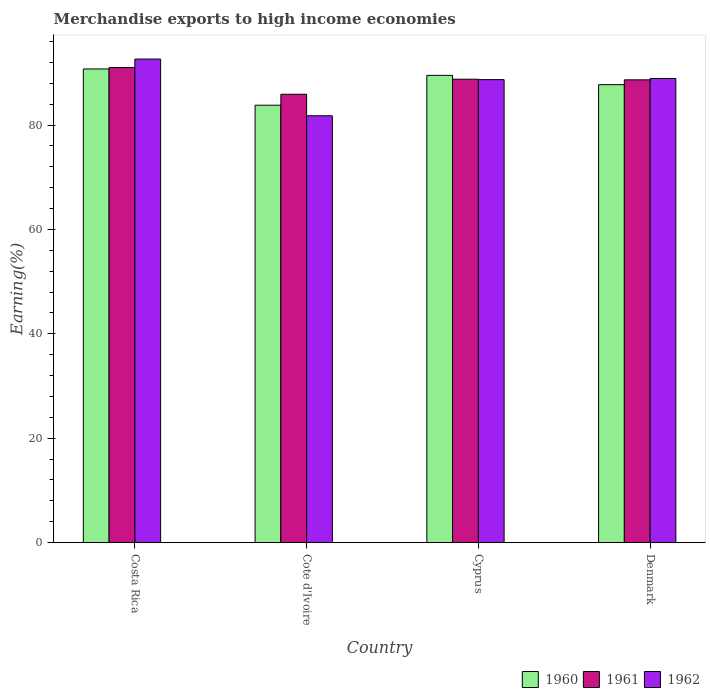How many different coloured bars are there?
Keep it short and to the point. 3. How many groups of bars are there?
Make the answer very short. 4. What is the label of the 1st group of bars from the left?
Your answer should be very brief. Costa Rica. What is the percentage of amount earned from merchandise exports in 1961 in Denmark?
Provide a succinct answer. 88.66. Across all countries, what is the maximum percentage of amount earned from merchandise exports in 1961?
Make the answer very short. 91.01. Across all countries, what is the minimum percentage of amount earned from merchandise exports in 1960?
Keep it short and to the point. 83.8. In which country was the percentage of amount earned from merchandise exports in 1961 minimum?
Your answer should be compact. Cote d'Ivoire. What is the total percentage of amount earned from merchandise exports in 1961 in the graph?
Your answer should be compact. 354.33. What is the difference between the percentage of amount earned from merchandise exports in 1961 in Costa Rica and that in Denmark?
Provide a succinct answer. 2.36. What is the difference between the percentage of amount earned from merchandise exports in 1960 in Cyprus and the percentage of amount earned from merchandise exports in 1961 in Cote d'Ivoire?
Keep it short and to the point. 3.62. What is the average percentage of amount earned from merchandise exports in 1960 per country?
Make the answer very short. 87.94. What is the difference between the percentage of amount earned from merchandise exports of/in 1960 and percentage of amount earned from merchandise exports of/in 1961 in Denmark?
Ensure brevity in your answer.  -0.93. What is the ratio of the percentage of amount earned from merchandise exports in 1961 in Costa Rica to that in Cote d'Ivoire?
Make the answer very short. 1.06. Is the percentage of amount earned from merchandise exports in 1960 in Costa Rica less than that in Cote d'Ivoire?
Provide a succinct answer. No. Is the difference between the percentage of amount earned from merchandise exports in 1960 in Cote d'Ivoire and Denmark greater than the difference between the percentage of amount earned from merchandise exports in 1961 in Cote d'Ivoire and Denmark?
Your answer should be compact. No. What is the difference between the highest and the second highest percentage of amount earned from merchandise exports in 1961?
Provide a short and direct response. 0.12. What is the difference between the highest and the lowest percentage of amount earned from merchandise exports in 1961?
Keep it short and to the point. 5.12. In how many countries, is the percentage of amount earned from merchandise exports in 1962 greater than the average percentage of amount earned from merchandise exports in 1962 taken over all countries?
Your answer should be compact. 3. Is the sum of the percentage of amount earned from merchandise exports in 1961 in Costa Rica and Denmark greater than the maximum percentage of amount earned from merchandise exports in 1962 across all countries?
Offer a very short reply. Yes. What does the 1st bar from the left in Cyprus represents?
Offer a very short reply. 1960. What does the 1st bar from the right in Denmark represents?
Keep it short and to the point. 1962. Is it the case that in every country, the sum of the percentage of amount earned from merchandise exports in 1960 and percentage of amount earned from merchandise exports in 1961 is greater than the percentage of amount earned from merchandise exports in 1962?
Ensure brevity in your answer.  Yes. How many bars are there?
Offer a terse response. 12. How many countries are there in the graph?
Give a very brief answer. 4. How are the legend labels stacked?
Provide a short and direct response. Horizontal. What is the title of the graph?
Offer a very short reply. Merchandise exports to high income economies. What is the label or title of the X-axis?
Your answer should be compact. Country. What is the label or title of the Y-axis?
Provide a succinct answer. Earning(%). What is the Earning(%) in 1960 in Costa Rica?
Keep it short and to the point. 90.74. What is the Earning(%) of 1961 in Costa Rica?
Ensure brevity in your answer.  91.01. What is the Earning(%) of 1962 in Costa Rica?
Ensure brevity in your answer.  92.64. What is the Earning(%) of 1960 in Cote d'Ivoire?
Your answer should be very brief. 83.8. What is the Earning(%) of 1961 in Cote d'Ivoire?
Provide a short and direct response. 85.89. What is the Earning(%) in 1962 in Cote d'Ivoire?
Make the answer very short. 81.77. What is the Earning(%) in 1960 in Cyprus?
Make the answer very short. 89.51. What is the Earning(%) of 1961 in Cyprus?
Your answer should be very brief. 88.78. What is the Earning(%) of 1962 in Cyprus?
Keep it short and to the point. 88.7. What is the Earning(%) in 1960 in Denmark?
Your answer should be very brief. 87.73. What is the Earning(%) in 1961 in Denmark?
Keep it short and to the point. 88.66. What is the Earning(%) of 1962 in Denmark?
Offer a very short reply. 88.91. Across all countries, what is the maximum Earning(%) of 1960?
Make the answer very short. 90.74. Across all countries, what is the maximum Earning(%) of 1961?
Provide a succinct answer. 91.01. Across all countries, what is the maximum Earning(%) in 1962?
Offer a very short reply. 92.64. Across all countries, what is the minimum Earning(%) of 1960?
Offer a terse response. 83.8. Across all countries, what is the minimum Earning(%) in 1961?
Offer a very short reply. 85.89. Across all countries, what is the minimum Earning(%) in 1962?
Make the answer very short. 81.77. What is the total Earning(%) in 1960 in the graph?
Offer a terse response. 351.78. What is the total Earning(%) in 1961 in the graph?
Provide a succinct answer. 354.33. What is the total Earning(%) of 1962 in the graph?
Provide a short and direct response. 352.01. What is the difference between the Earning(%) of 1960 in Costa Rica and that in Cote d'Ivoire?
Your answer should be very brief. 6.95. What is the difference between the Earning(%) in 1961 in Costa Rica and that in Cote d'Ivoire?
Offer a terse response. 5.12. What is the difference between the Earning(%) of 1962 in Costa Rica and that in Cote d'Ivoire?
Your answer should be very brief. 10.87. What is the difference between the Earning(%) of 1960 in Costa Rica and that in Cyprus?
Your response must be concise. 1.23. What is the difference between the Earning(%) in 1961 in Costa Rica and that in Cyprus?
Your answer should be compact. 2.24. What is the difference between the Earning(%) in 1962 in Costa Rica and that in Cyprus?
Give a very brief answer. 3.94. What is the difference between the Earning(%) in 1960 in Costa Rica and that in Denmark?
Your response must be concise. 3.01. What is the difference between the Earning(%) in 1961 in Costa Rica and that in Denmark?
Keep it short and to the point. 2.36. What is the difference between the Earning(%) in 1962 in Costa Rica and that in Denmark?
Offer a very short reply. 3.73. What is the difference between the Earning(%) in 1960 in Cote d'Ivoire and that in Cyprus?
Your answer should be compact. -5.72. What is the difference between the Earning(%) of 1961 in Cote d'Ivoire and that in Cyprus?
Your answer should be very brief. -2.88. What is the difference between the Earning(%) in 1962 in Cote d'Ivoire and that in Cyprus?
Offer a very short reply. -6.92. What is the difference between the Earning(%) in 1960 in Cote d'Ivoire and that in Denmark?
Make the answer very short. -3.93. What is the difference between the Earning(%) in 1961 in Cote d'Ivoire and that in Denmark?
Your response must be concise. -2.76. What is the difference between the Earning(%) of 1962 in Cote d'Ivoire and that in Denmark?
Keep it short and to the point. -7.14. What is the difference between the Earning(%) of 1960 in Cyprus and that in Denmark?
Your answer should be compact. 1.78. What is the difference between the Earning(%) in 1961 in Cyprus and that in Denmark?
Offer a terse response. 0.12. What is the difference between the Earning(%) of 1962 in Cyprus and that in Denmark?
Offer a very short reply. -0.21. What is the difference between the Earning(%) of 1960 in Costa Rica and the Earning(%) of 1961 in Cote d'Ivoire?
Provide a succinct answer. 4.85. What is the difference between the Earning(%) of 1960 in Costa Rica and the Earning(%) of 1962 in Cote d'Ivoire?
Offer a terse response. 8.97. What is the difference between the Earning(%) of 1961 in Costa Rica and the Earning(%) of 1962 in Cote d'Ivoire?
Ensure brevity in your answer.  9.24. What is the difference between the Earning(%) in 1960 in Costa Rica and the Earning(%) in 1961 in Cyprus?
Your response must be concise. 1.97. What is the difference between the Earning(%) of 1960 in Costa Rica and the Earning(%) of 1962 in Cyprus?
Offer a terse response. 2.05. What is the difference between the Earning(%) of 1961 in Costa Rica and the Earning(%) of 1962 in Cyprus?
Give a very brief answer. 2.32. What is the difference between the Earning(%) of 1960 in Costa Rica and the Earning(%) of 1961 in Denmark?
Give a very brief answer. 2.09. What is the difference between the Earning(%) in 1960 in Costa Rica and the Earning(%) in 1962 in Denmark?
Provide a short and direct response. 1.83. What is the difference between the Earning(%) of 1961 in Costa Rica and the Earning(%) of 1962 in Denmark?
Give a very brief answer. 2.1. What is the difference between the Earning(%) in 1960 in Cote d'Ivoire and the Earning(%) in 1961 in Cyprus?
Provide a short and direct response. -4.98. What is the difference between the Earning(%) of 1960 in Cote d'Ivoire and the Earning(%) of 1962 in Cyprus?
Provide a succinct answer. -4.9. What is the difference between the Earning(%) in 1961 in Cote d'Ivoire and the Earning(%) in 1962 in Cyprus?
Keep it short and to the point. -2.8. What is the difference between the Earning(%) in 1960 in Cote d'Ivoire and the Earning(%) in 1961 in Denmark?
Offer a very short reply. -4.86. What is the difference between the Earning(%) in 1960 in Cote d'Ivoire and the Earning(%) in 1962 in Denmark?
Provide a short and direct response. -5.11. What is the difference between the Earning(%) in 1961 in Cote d'Ivoire and the Earning(%) in 1962 in Denmark?
Keep it short and to the point. -3.02. What is the difference between the Earning(%) of 1960 in Cyprus and the Earning(%) of 1961 in Denmark?
Your answer should be compact. 0.86. What is the difference between the Earning(%) of 1960 in Cyprus and the Earning(%) of 1962 in Denmark?
Your answer should be very brief. 0.6. What is the difference between the Earning(%) of 1961 in Cyprus and the Earning(%) of 1962 in Denmark?
Your response must be concise. -0.13. What is the average Earning(%) in 1960 per country?
Make the answer very short. 87.94. What is the average Earning(%) in 1961 per country?
Make the answer very short. 88.58. What is the average Earning(%) in 1962 per country?
Provide a short and direct response. 88. What is the difference between the Earning(%) in 1960 and Earning(%) in 1961 in Costa Rica?
Offer a terse response. -0.27. What is the difference between the Earning(%) of 1960 and Earning(%) of 1962 in Costa Rica?
Make the answer very short. -1.9. What is the difference between the Earning(%) in 1961 and Earning(%) in 1962 in Costa Rica?
Your answer should be compact. -1.63. What is the difference between the Earning(%) of 1960 and Earning(%) of 1961 in Cote d'Ivoire?
Make the answer very short. -2.1. What is the difference between the Earning(%) in 1960 and Earning(%) in 1962 in Cote d'Ivoire?
Give a very brief answer. 2.02. What is the difference between the Earning(%) of 1961 and Earning(%) of 1962 in Cote d'Ivoire?
Provide a short and direct response. 4.12. What is the difference between the Earning(%) in 1960 and Earning(%) in 1961 in Cyprus?
Provide a succinct answer. 0.74. What is the difference between the Earning(%) in 1960 and Earning(%) in 1962 in Cyprus?
Your answer should be compact. 0.82. What is the difference between the Earning(%) in 1961 and Earning(%) in 1962 in Cyprus?
Your response must be concise. 0.08. What is the difference between the Earning(%) of 1960 and Earning(%) of 1961 in Denmark?
Your response must be concise. -0.93. What is the difference between the Earning(%) in 1960 and Earning(%) in 1962 in Denmark?
Your response must be concise. -1.18. What is the difference between the Earning(%) in 1961 and Earning(%) in 1962 in Denmark?
Provide a short and direct response. -0.25. What is the ratio of the Earning(%) of 1960 in Costa Rica to that in Cote d'Ivoire?
Make the answer very short. 1.08. What is the ratio of the Earning(%) in 1961 in Costa Rica to that in Cote d'Ivoire?
Ensure brevity in your answer.  1.06. What is the ratio of the Earning(%) in 1962 in Costa Rica to that in Cote d'Ivoire?
Ensure brevity in your answer.  1.13. What is the ratio of the Earning(%) in 1960 in Costa Rica to that in Cyprus?
Give a very brief answer. 1.01. What is the ratio of the Earning(%) of 1961 in Costa Rica to that in Cyprus?
Your answer should be very brief. 1.03. What is the ratio of the Earning(%) of 1962 in Costa Rica to that in Cyprus?
Offer a terse response. 1.04. What is the ratio of the Earning(%) of 1960 in Costa Rica to that in Denmark?
Your answer should be very brief. 1.03. What is the ratio of the Earning(%) in 1961 in Costa Rica to that in Denmark?
Keep it short and to the point. 1.03. What is the ratio of the Earning(%) of 1962 in Costa Rica to that in Denmark?
Make the answer very short. 1.04. What is the ratio of the Earning(%) of 1960 in Cote d'Ivoire to that in Cyprus?
Your response must be concise. 0.94. What is the ratio of the Earning(%) of 1961 in Cote d'Ivoire to that in Cyprus?
Ensure brevity in your answer.  0.97. What is the ratio of the Earning(%) in 1962 in Cote d'Ivoire to that in Cyprus?
Ensure brevity in your answer.  0.92. What is the ratio of the Earning(%) of 1960 in Cote d'Ivoire to that in Denmark?
Make the answer very short. 0.96. What is the ratio of the Earning(%) of 1961 in Cote d'Ivoire to that in Denmark?
Make the answer very short. 0.97. What is the ratio of the Earning(%) of 1962 in Cote d'Ivoire to that in Denmark?
Your answer should be compact. 0.92. What is the ratio of the Earning(%) of 1960 in Cyprus to that in Denmark?
Make the answer very short. 1.02. What is the ratio of the Earning(%) of 1962 in Cyprus to that in Denmark?
Make the answer very short. 1. What is the difference between the highest and the second highest Earning(%) of 1960?
Give a very brief answer. 1.23. What is the difference between the highest and the second highest Earning(%) in 1961?
Provide a succinct answer. 2.24. What is the difference between the highest and the second highest Earning(%) in 1962?
Provide a short and direct response. 3.73. What is the difference between the highest and the lowest Earning(%) of 1960?
Your answer should be very brief. 6.95. What is the difference between the highest and the lowest Earning(%) of 1961?
Provide a short and direct response. 5.12. What is the difference between the highest and the lowest Earning(%) of 1962?
Your response must be concise. 10.87. 